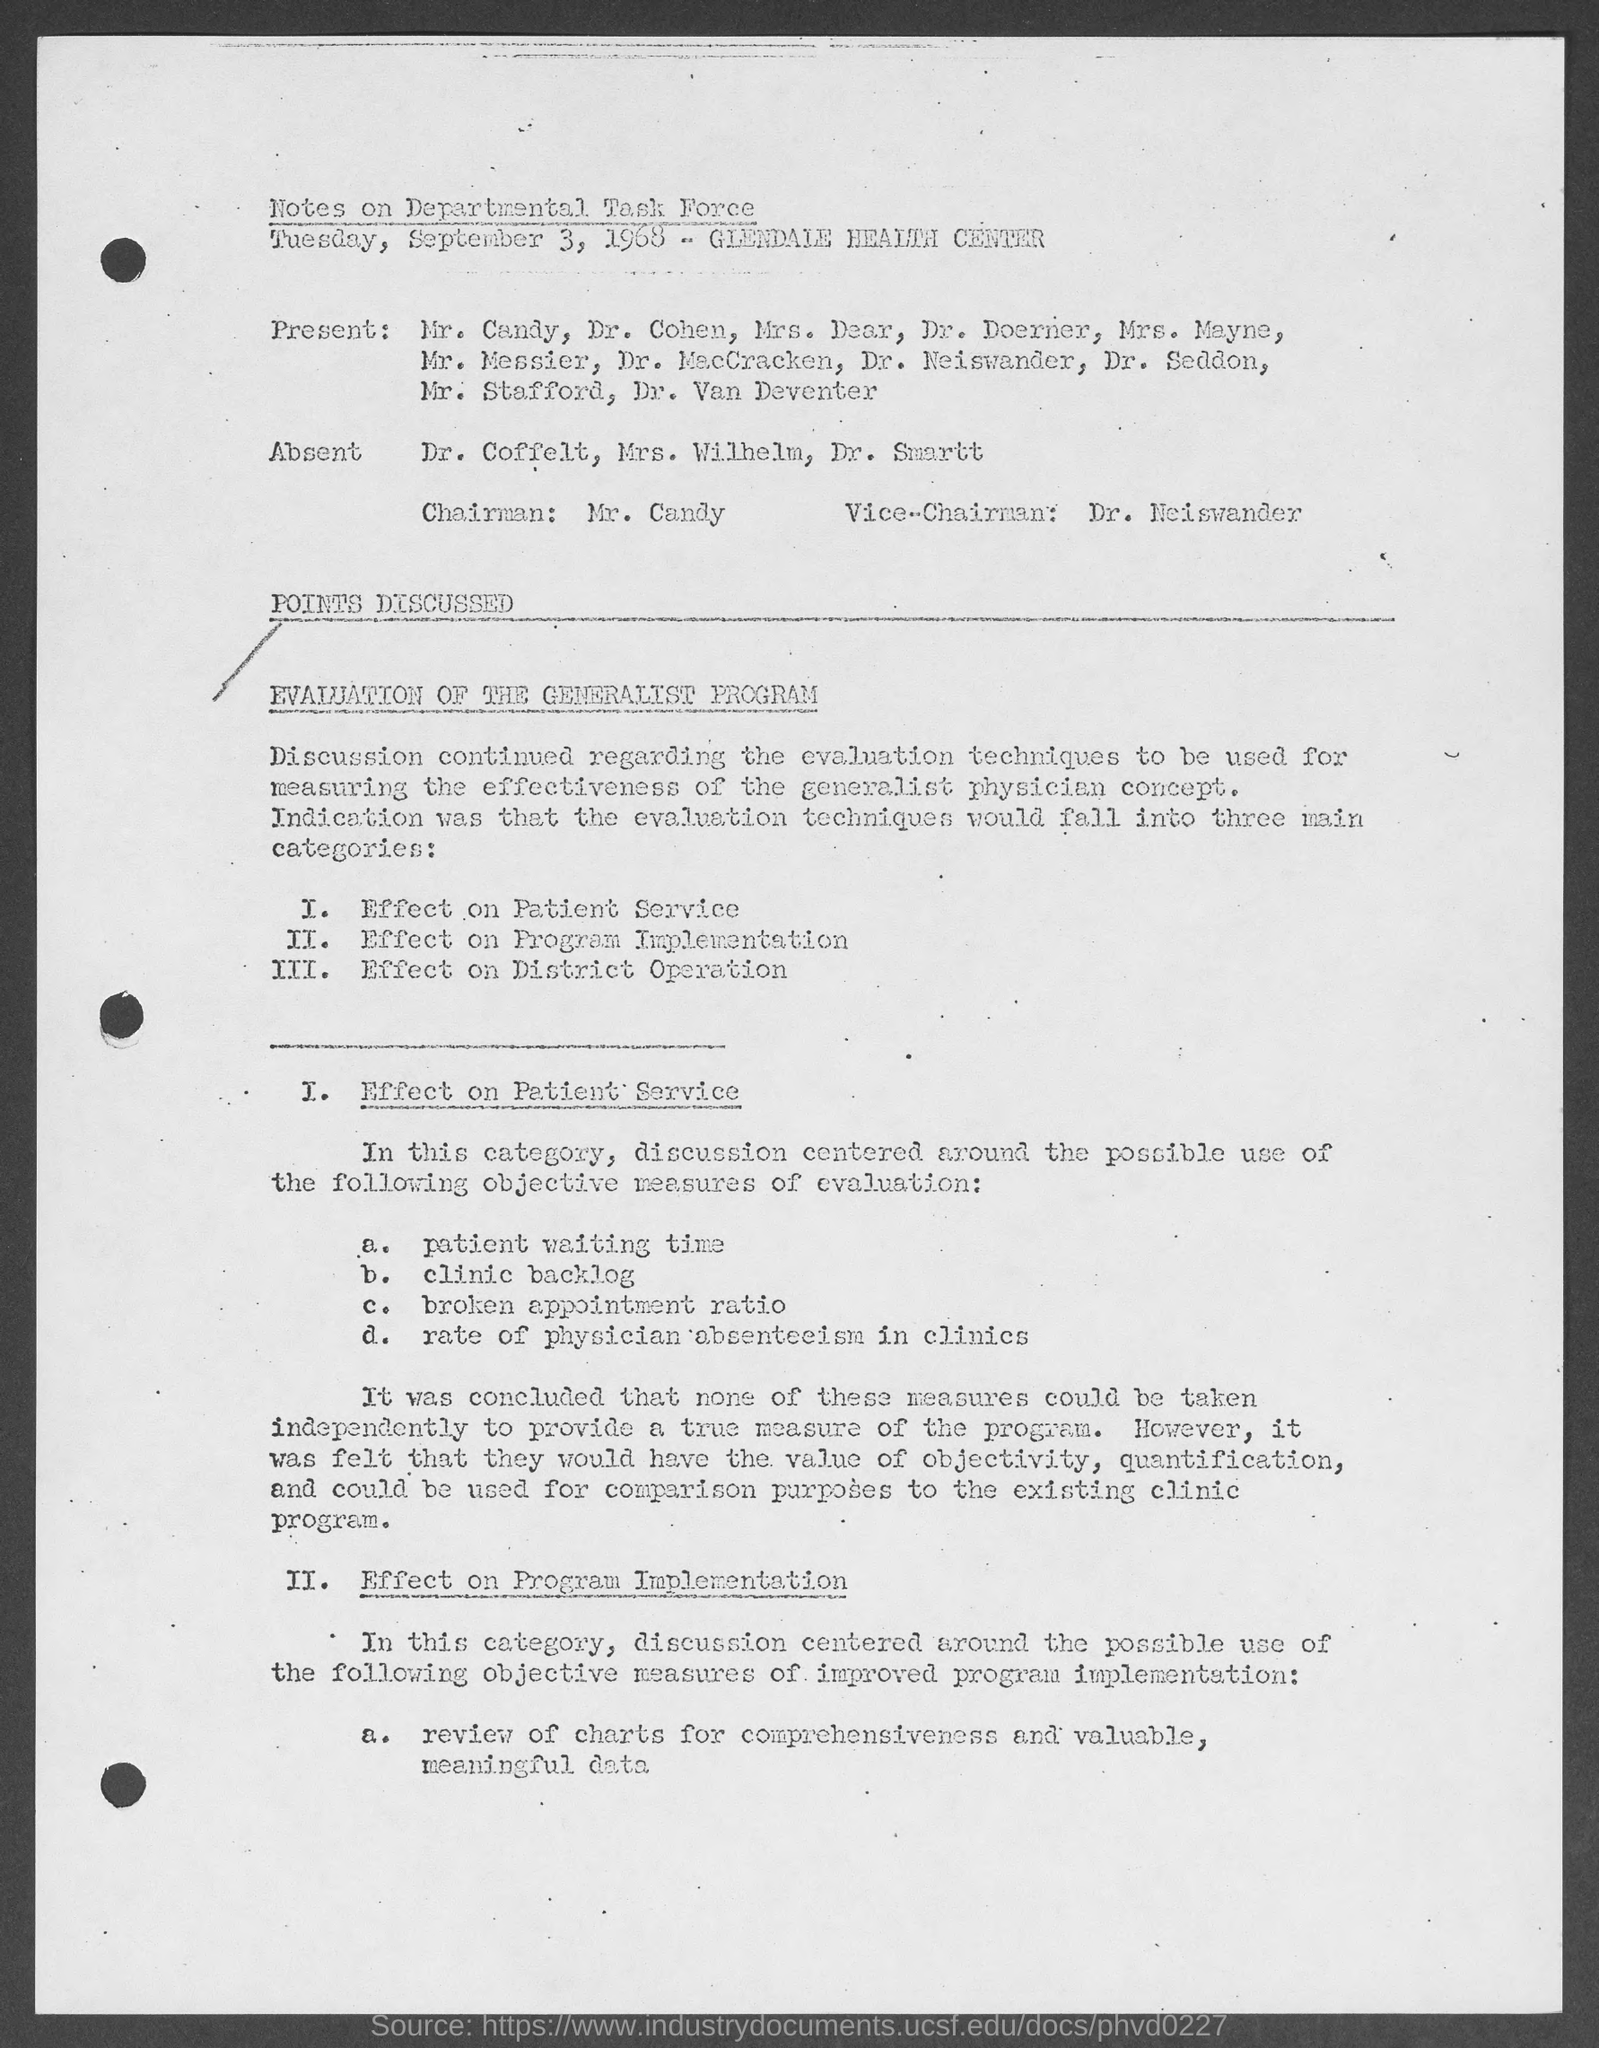Can you summarize the main points discussed in this document? The document summarizes the discussion of a Departmental Task Force meeting focused on evaluating the Generalist Program. Key points include analyzing the effect of the program on patient service, program implementation, and district operation. They aimed to find objective measures for evaluation, like patient waiting time and review of charts, but concluded that none of these measures could be taken independently to accurately gauge the program's effectiveness. 